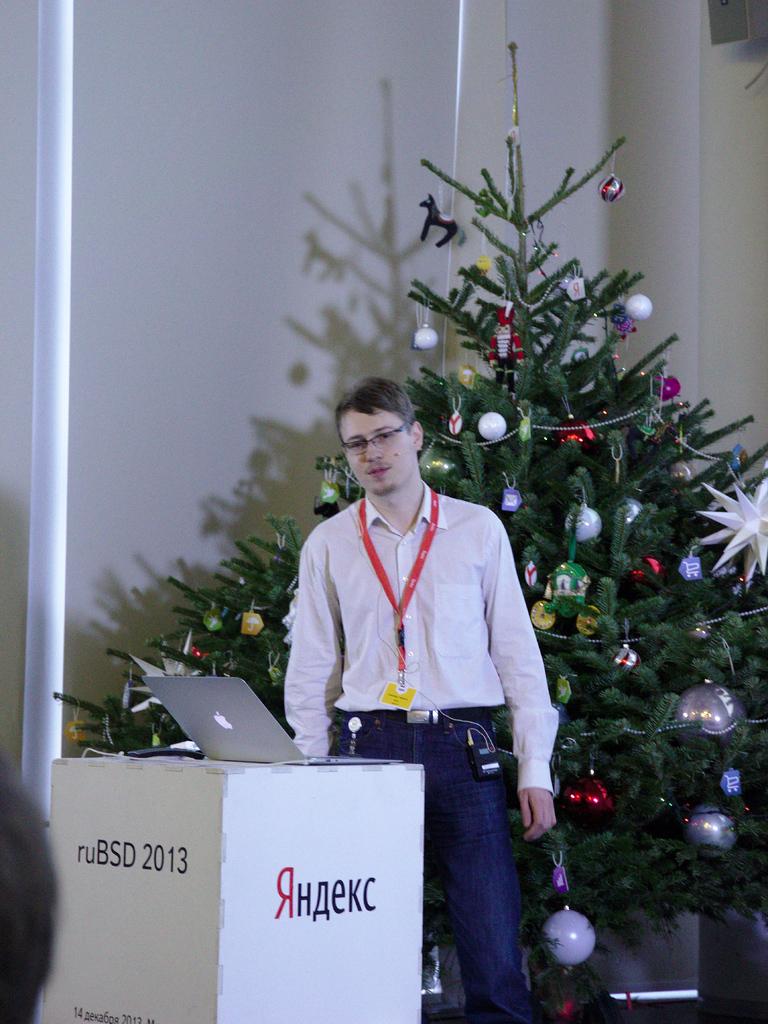What are the letters before the date?
Your answer should be compact. Rubsd. 